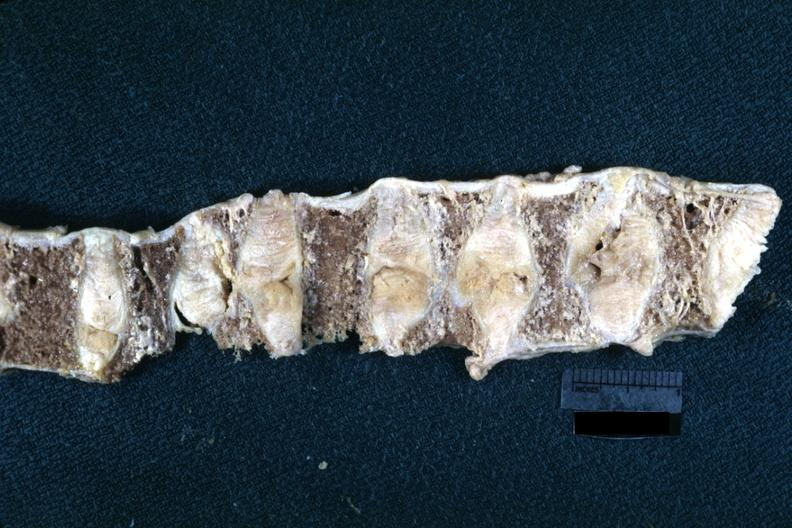what does this image show?
Answer the question using a single word or phrase. Fixed tissue lateral view of vertebral bodies with many collapsed case of rheumatoid arthritis 